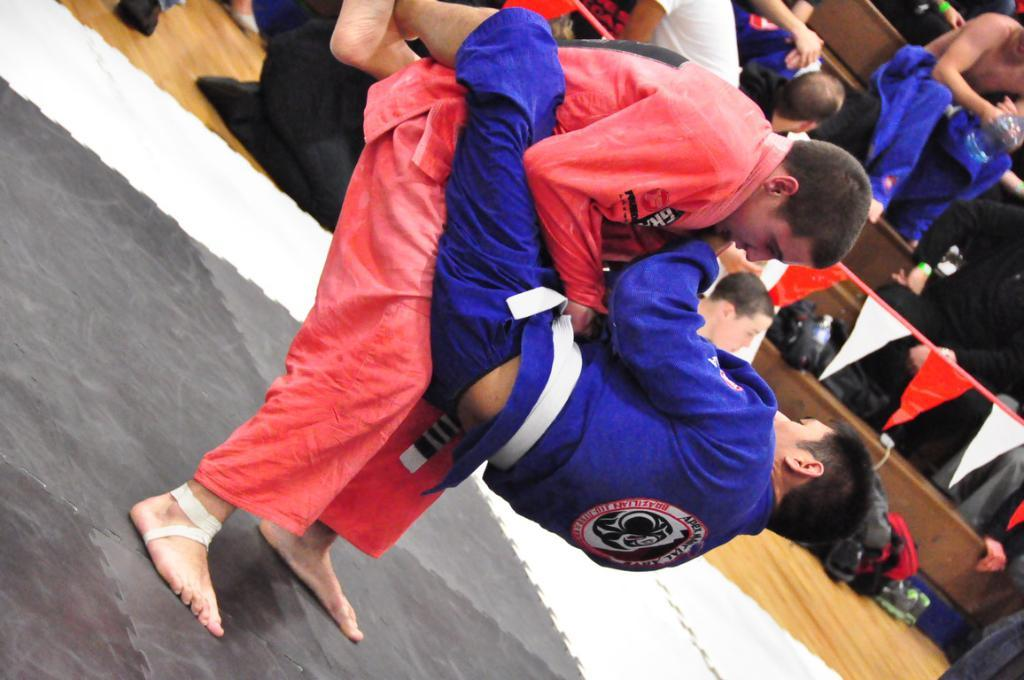What is the man in the image doing? The man is lifting a person in the image. What can be seen hanging in the background of the image? There is a paper banner in the image. Where are some people sitting in the image? There are people sitting on wooden stairs in the image. What is placed on the floor in the image? There is a bag placed on the floor in the image. How many girls are riding the trains in the image? There are no girls or trains present in the image. 